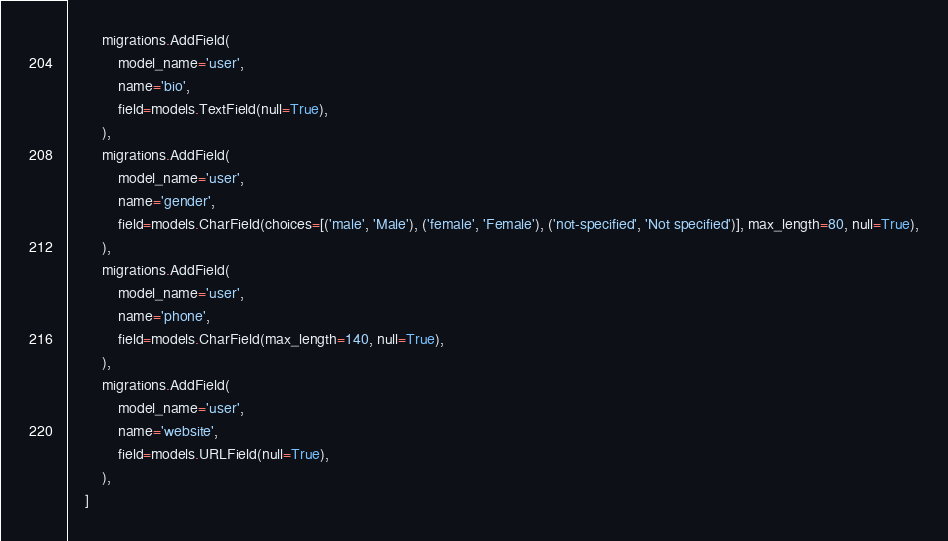<code> <loc_0><loc_0><loc_500><loc_500><_Python_>        migrations.AddField(
            model_name='user',
            name='bio',
            field=models.TextField(null=True),
        ),
        migrations.AddField(
            model_name='user',
            name='gender',
            field=models.CharField(choices=[('male', 'Male'), ('female', 'Female'), ('not-specified', 'Not specified')], max_length=80, null=True),
        ),
        migrations.AddField(
            model_name='user',
            name='phone',
            field=models.CharField(max_length=140, null=True),
        ),
        migrations.AddField(
            model_name='user',
            name='website',
            field=models.URLField(null=True),
        ),
    ]
</code> 